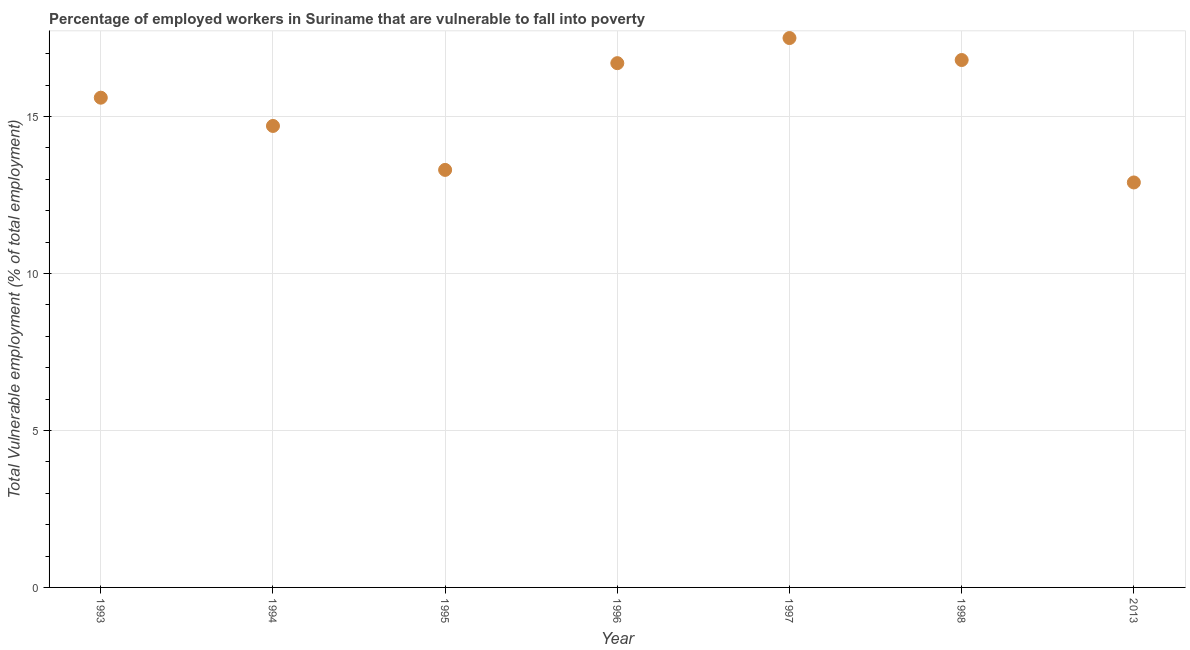What is the total vulnerable employment in 1997?
Your answer should be very brief. 17.5. Across all years, what is the maximum total vulnerable employment?
Offer a terse response. 17.5. Across all years, what is the minimum total vulnerable employment?
Keep it short and to the point. 12.9. What is the sum of the total vulnerable employment?
Offer a terse response. 107.5. What is the difference between the total vulnerable employment in 1995 and 1996?
Your answer should be compact. -3.4. What is the average total vulnerable employment per year?
Offer a terse response. 15.36. What is the median total vulnerable employment?
Your answer should be compact. 15.6. In how many years, is the total vulnerable employment greater than 4 %?
Provide a succinct answer. 7. Do a majority of the years between 1995 and 2013 (inclusive) have total vulnerable employment greater than 13 %?
Provide a succinct answer. Yes. What is the ratio of the total vulnerable employment in 1997 to that in 1998?
Provide a short and direct response. 1.04. Is the difference between the total vulnerable employment in 1994 and 1995 greater than the difference between any two years?
Your response must be concise. No. What is the difference between the highest and the second highest total vulnerable employment?
Give a very brief answer. 0.7. What is the difference between the highest and the lowest total vulnerable employment?
Give a very brief answer. 4.6. How many years are there in the graph?
Your answer should be compact. 7. What is the difference between two consecutive major ticks on the Y-axis?
Provide a succinct answer. 5. Are the values on the major ticks of Y-axis written in scientific E-notation?
Your answer should be compact. No. What is the title of the graph?
Make the answer very short. Percentage of employed workers in Suriname that are vulnerable to fall into poverty. What is the label or title of the Y-axis?
Provide a short and direct response. Total Vulnerable employment (% of total employment). What is the Total Vulnerable employment (% of total employment) in 1993?
Make the answer very short. 15.6. What is the Total Vulnerable employment (% of total employment) in 1994?
Provide a short and direct response. 14.7. What is the Total Vulnerable employment (% of total employment) in 1995?
Offer a terse response. 13.3. What is the Total Vulnerable employment (% of total employment) in 1996?
Your answer should be compact. 16.7. What is the Total Vulnerable employment (% of total employment) in 1998?
Ensure brevity in your answer.  16.8. What is the Total Vulnerable employment (% of total employment) in 2013?
Offer a very short reply. 12.9. What is the difference between the Total Vulnerable employment (% of total employment) in 1993 and 1995?
Ensure brevity in your answer.  2.3. What is the difference between the Total Vulnerable employment (% of total employment) in 1993 and 1996?
Offer a very short reply. -1.1. What is the difference between the Total Vulnerable employment (% of total employment) in 1993 and 1998?
Your answer should be very brief. -1.2. What is the difference between the Total Vulnerable employment (% of total employment) in 1993 and 2013?
Make the answer very short. 2.7. What is the difference between the Total Vulnerable employment (% of total employment) in 1994 and 1995?
Provide a succinct answer. 1.4. What is the difference between the Total Vulnerable employment (% of total employment) in 1994 and 1996?
Your answer should be compact. -2. What is the difference between the Total Vulnerable employment (% of total employment) in 1994 and 1998?
Keep it short and to the point. -2.1. What is the difference between the Total Vulnerable employment (% of total employment) in 1994 and 2013?
Your answer should be compact. 1.8. What is the difference between the Total Vulnerable employment (% of total employment) in 1995 and 1996?
Offer a very short reply. -3.4. What is the difference between the Total Vulnerable employment (% of total employment) in 1995 and 2013?
Provide a short and direct response. 0.4. What is the difference between the Total Vulnerable employment (% of total employment) in 1996 and 1997?
Your answer should be very brief. -0.8. What is the difference between the Total Vulnerable employment (% of total employment) in 1997 and 1998?
Make the answer very short. 0.7. What is the difference between the Total Vulnerable employment (% of total employment) in 1998 and 2013?
Make the answer very short. 3.9. What is the ratio of the Total Vulnerable employment (% of total employment) in 1993 to that in 1994?
Ensure brevity in your answer.  1.06. What is the ratio of the Total Vulnerable employment (% of total employment) in 1993 to that in 1995?
Your response must be concise. 1.17. What is the ratio of the Total Vulnerable employment (% of total employment) in 1993 to that in 1996?
Provide a short and direct response. 0.93. What is the ratio of the Total Vulnerable employment (% of total employment) in 1993 to that in 1997?
Offer a very short reply. 0.89. What is the ratio of the Total Vulnerable employment (% of total employment) in 1993 to that in 1998?
Your answer should be very brief. 0.93. What is the ratio of the Total Vulnerable employment (% of total employment) in 1993 to that in 2013?
Provide a short and direct response. 1.21. What is the ratio of the Total Vulnerable employment (% of total employment) in 1994 to that in 1995?
Offer a very short reply. 1.1. What is the ratio of the Total Vulnerable employment (% of total employment) in 1994 to that in 1996?
Offer a terse response. 0.88. What is the ratio of the Total Vulnerable employment (% of total employment) in 1994 to that in 1997?
Your answer should be compact. 0.84. What is the ratio of the Total Vulnerable employment (% of total employment) in 1994 to that in 1998?
Make the answer very short. 0.88. What is the ratio of the Total Vulnerable employment (% of total employment) in 1994 to that in 2013?
Keep it short and to the point. 1.14. What is the ratio of the Total Vulnerable employment (% of total employment) in 1995 to that in 1996?
Your answer should be compact. 0.8. What is the ratio of the Total Vulnerable employment (% of total employment) in 1995 to that in 1997?
Keep it short and to the point. 0.76. What is the ratio of the Total Vulnerable employment (% of total employment) in 1995 to that in 1998?
Offer a very short reply. 0.79. What is the ratio of the Total Vulnerable employment (% of total employment) in 1995 to that in 2013?
Your response must be concise. 1.03. What is the ratio of the Total Vulnerable employment (% of total employment) in 1996 to that in 1997?
Offer a terse response. 0.95. What is the ratio of the Total Vulnerable employment (% of total employment) in 1996 to that in 2013?
Provide a short and direct response. 1.29. What is the ratio of the Total Vulnerable employment (% of total employment) in 1997 to that in 1998?
Offer a terse response. 1.04. What is the ratio of the Total Vulnerable employment (% of total employment) in 1997 to that in 2013?
Offer a terse response. 1.36. What is the ratio of the Total Vulnerable employment (% of total employment) in 1998 to that in 2013?
Give a very brief answer. 1.3. 